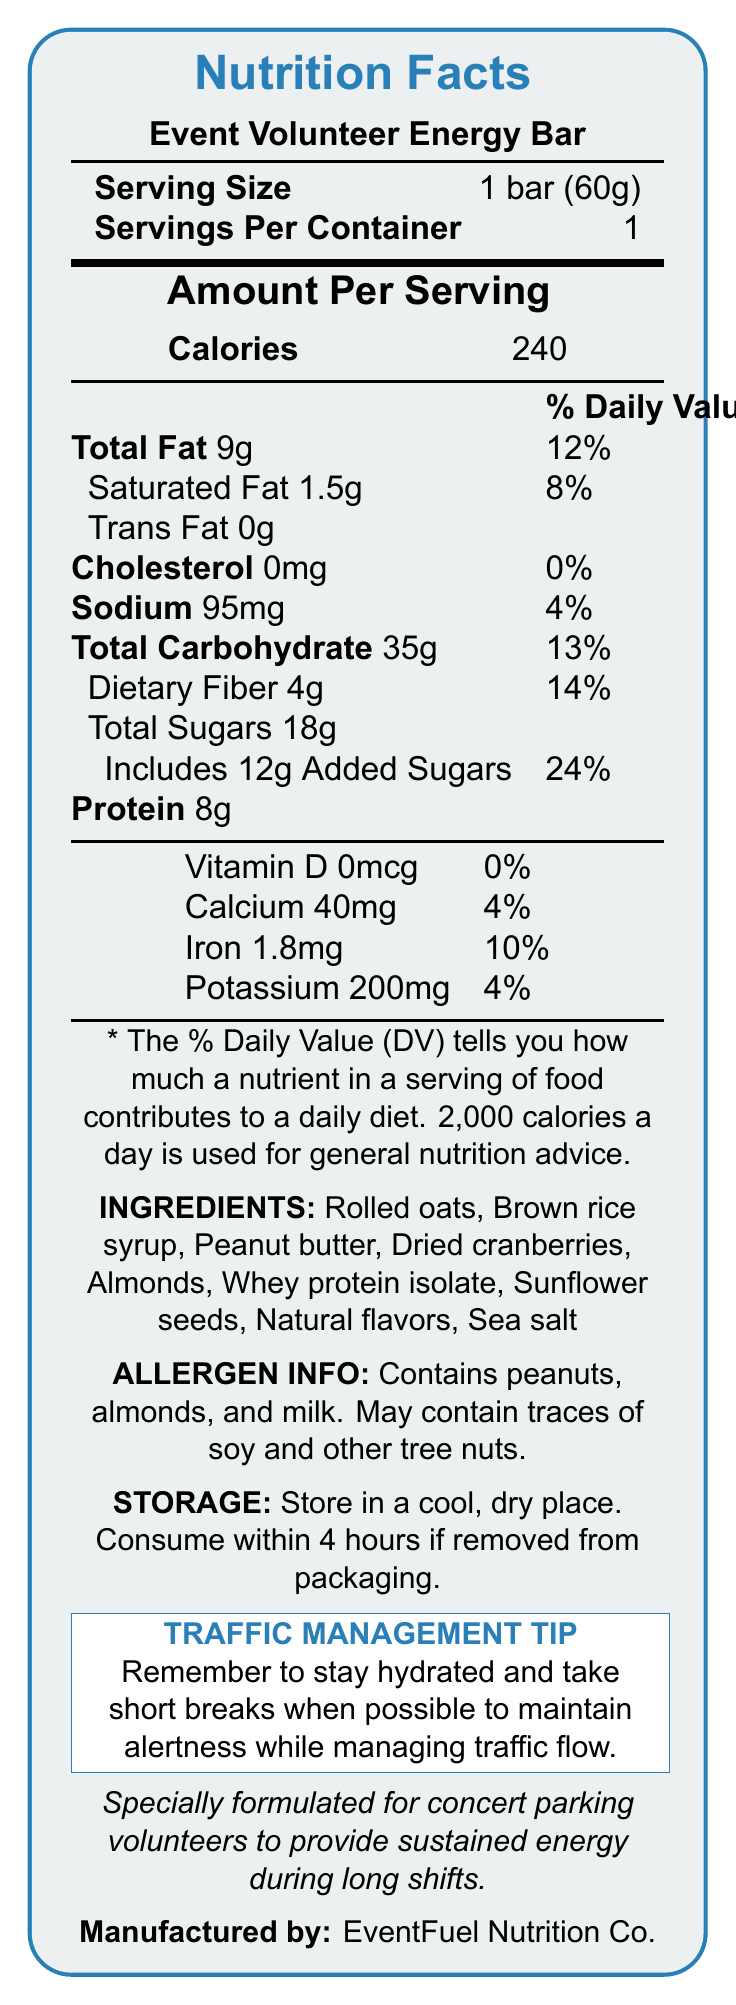what is the serving size? The document specifies that the serving size for the Event Volunteer Energy Bar is 1 bar weighing 60 grams.
Answer: 1 bar (60g) how many calories are in one serving of the energy bar? Under "Amount Per Serving," it lists that the energy bar contains 240 calories per serving.
Answer: 240 calories what is the total fat content and its daily value percentage? The total fat content is listed as 9 grams, which corresponds to 12% of the daily value.
Answer: 9g, 12% how much protein is in the energy bar? The protein content is listed as 8 grams in the document.
Answer: 8g what allergens are present in the energy bar? Under "ALLERGEN INFO," it specifies that the bar contains peanuts, almonds, and milk, and may contain traces of soy and other tree nuts.
Answer: Peanuts, almonds, and milk what should you do if you remove the bar from its packaging? The storage instructions state that the bar should be consumed within 4 hours if removed from packaging.
Answer: Consume within 4 hours identify the manufacturer of the energy bar. The document lists EventFuel Nutrition Co. as the manufacturer.
Answer: EventFuel Nutrition Co. from which ingredient is the bar primarily sweetened? A. Peanut Butter B. Brown Rice Syrup C. Dried Cranberries D. Honey The ingredients list Brown Rice Syrup near the top, implying it as a primary sweetener.
Answer: B. Brown Rice Syrup what percentage of the daily value does the added sugars contribute? A. 12% B. 18% C. 24% D. 32% Added sugars account for 24% of the daily value according to the document.
Answer: C. 24% how much potassium is in the energy bar? A. 150mg B. 200mg C. 250mg D. 300mg The document specifies that the bar contains 200mg of potassium, contributing to 4% of the daily value.
Answer: B. 200mg does the energy bar contain any trans fat? The document states that the trans fat content is 0g.
Answer: No is this energy bar specifically designed for a particular group? The document mentions that the bar is specially formulated for concert parking volunteers to provide sustained energy during long shifts.
Answer: Yes what does the traffic management tip on the document suggest? The traffic management tip advises volunteers to stay hydrated and take short breaks when possible to maintain alertness while managing traffic flow.
Answer: Stay hydrated and take short breaks when possible can you find the production date on this document? The document does not provide any information regarding the production date of the energy bar.
Answer: Not enough information summarize the main idea of the document. The document primarily focuses on providing detailed nutritional information about the Event Volunteer Energy Bar, its ingredients, allergen warnings, and specific instructions for storage, along with a helpful tip for traffic management during events.
Answer: The document is a Nutrition Facts Label for the Event Volunteer Energy Bar, detailing its nutritional content, ingredients, allergen information, storage instructions, and specific benefits for concert parking volunteers. It also includes a traffic management tip for volunteers. 